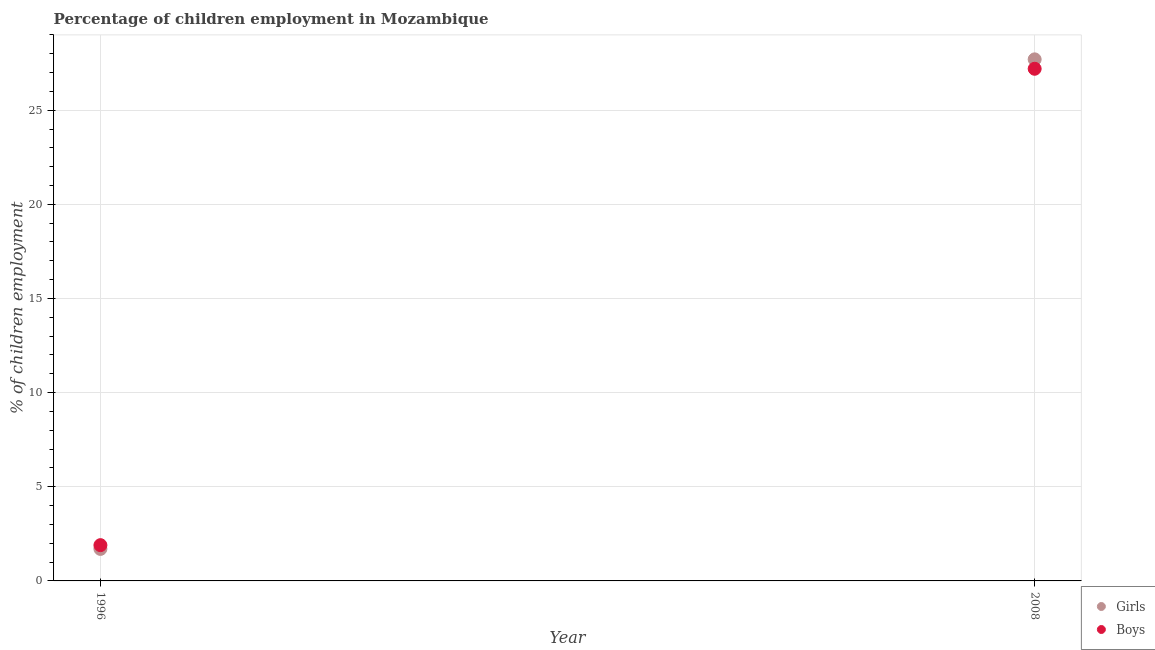What is the percentage of employed girls in 2008?
Offer a very short reply. 27.7. Across all years, what is the maximum percentage of employed boys?
Keep it short and to the point. 27.2. Across all years, what is the minimum percentage of employed boys?
Give a very brief answer. 1.9. In which year was the percentage of employed boys minimum?
Ensure brevity in your answer.  1996. What is the total percentage of employed girls in the graph?
Your answer should be very brief. 29.4. What is the difference between the percentage of employed boys in 1996 and that in 2008?
Your response must be concise. -25.3. What is the difference between the percentage of employed boys in 1996 and the percentage of employed girls in 2008?
Your response must be concise. -25.8. In how many years, is the percentage of employed girls greater than 15 %?
Provide a succinct answer. 1. What is the ratio of the percentage of employed girls in 1996 to that in 2008?
Keep it short and to the point. 0.06. What is the difference between two consecutive major ticks on the Y-axis?
Make the answer very short. 5. Are the values on the major ticks of Y-axis written in scientific E-notation?
Your answer should be very brief. No. What is the title of the graph?
Ensure brevity in your answer.  Percentage of children employment in Mozambique. What is the label or title of the Y-axis?
Offer a terse response. % of children employment. What is the % of children employment of Girls in 2008?
Make the answer very short. 27.7. What is the % of children employment of Boys in 2008?
Keep it short and to the point. 27.2. Across all years, what is the maximum % of children employment in Girls?
Keep it short and to the point. 27.7. Across all years, what is the maximum % of children employment in Boys?
Your answer should be very brief. 27.2. Across all years, what is the minimum % of children employment of Girls?
Offer a terse response. 1.7. What is the total % of children employment of Girls in the graph?
Give a very brief answer. 29.4. What is the total % of children employment in Boys in the graph?
Offer a very short reply. 29.1. What is the difference between the % of children employment of Girls in 1996 and that in 2008?
Offer a terse response. -26. What is the difference between the % of children employment in Boys in 1996 and that in 2008?
Your response must be concise. -25.3. What is the difference between the % of children employment of Girls in 1996 and the % of children employment of Boys in 2008?
Provide a succinct answer. -25.5. What is the average % of children employment in Boys per year?
Your answer should be very brief. 14.55. In the year 2008, what is the difference between the % of children employment in Girls and % of children employment in Boys?
Provide a short and direct response. 0.5. What is the ratio of the % of children employment in Girls in 1996 to that in 2008?
Ensure brevity in your answer.  0.06. What is the ratio of the % of children employment in Boys in 1996 to that in 2008?
Your answer should be very brief. 0.07. What is the difference between the highest and the second highest % of children employment of Girls?
Ensure brevity in your answer.  26. What is the difference between the highest and the second highest % of children employment in Boys?
Provide a short and direct response. 25.3. What is the difference between the highest and the lowest % of children employment of Boys?
Your response must be concise. 25.3. 